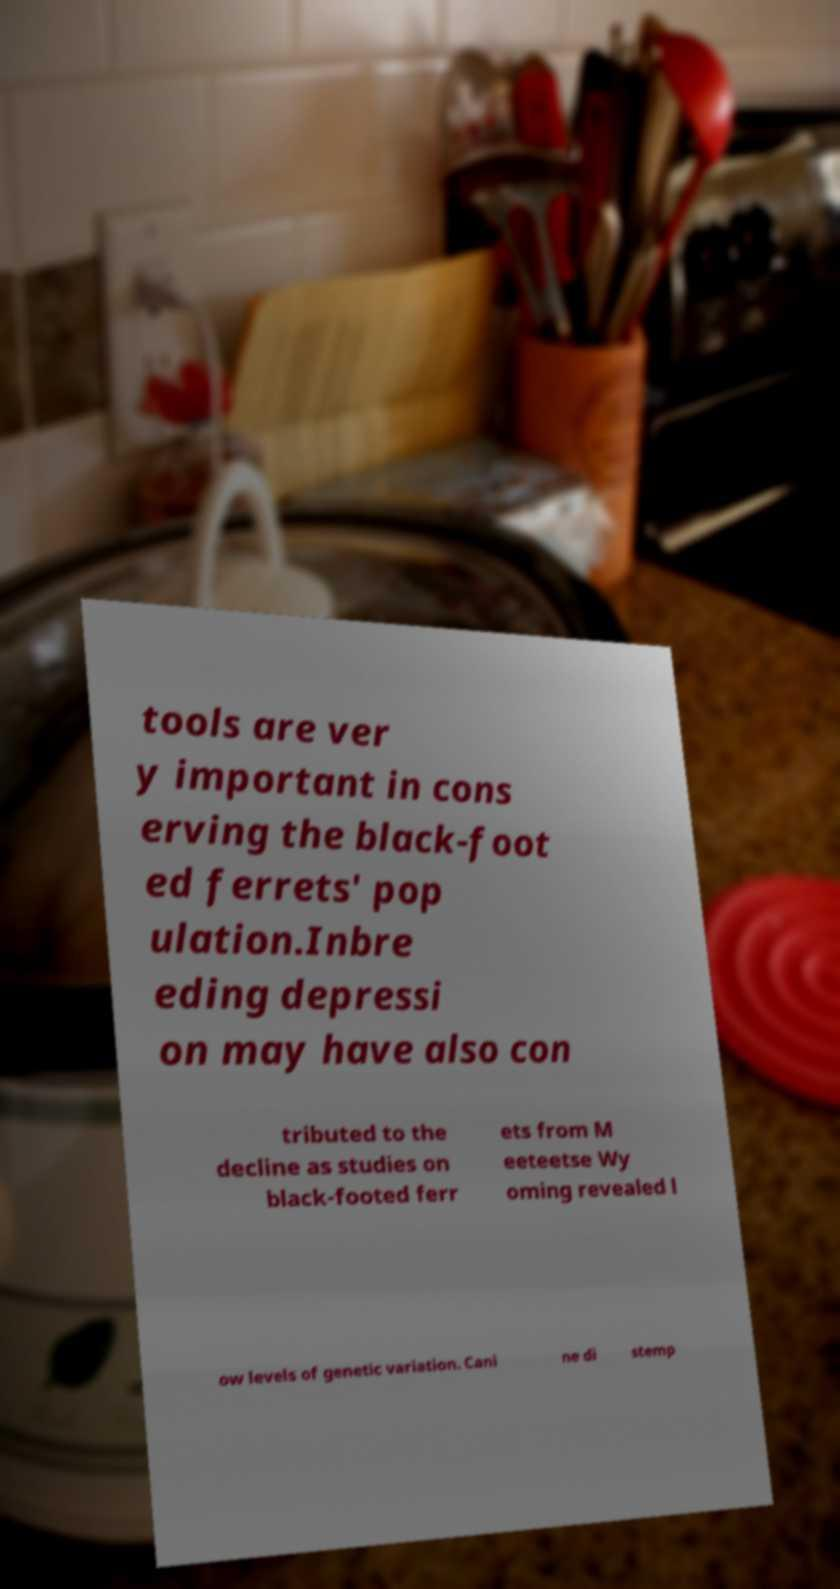For documentation purposes, I need the text within this image transcribed. Could you provide that? tools are ver y important in cons erving the black-foot ed ferrets' pop ulation.Inbre eding depressi on may have also con tributed to the decline as studies on black-footed ferr ets from M eeteetse Wy oming revealed l ow levels of genetic variation. Cani ne di stemp 